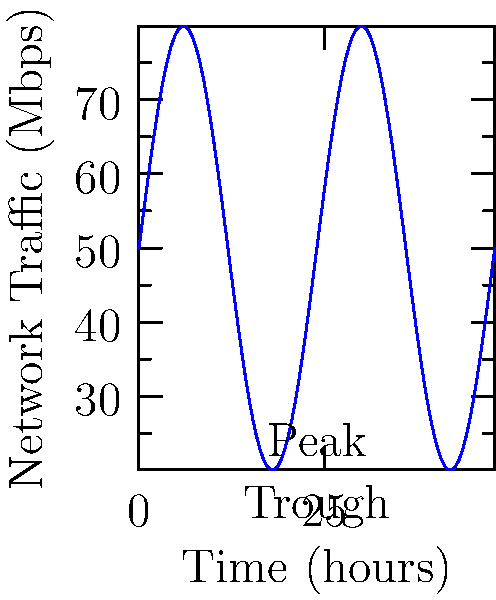As an ethical hacker analyzing network traffic patterns for a start-up, you observe that the traffic follows a sinusoidal pattern over a 24-hour period. The average traffic is 50 Mbps, with peaks reaching 80 Mbps and troughs at 20 Mbps. Using this information, construct a trigonometric function to model the network traffic $T(t)$ in Mbps as a function of time $t$ in hours. What is the period of this function? To construct the trigonometric function and find its period, we'll follow these steps:

1) The general form of a sinusoidal function is:
   $T(t) = A \sin(B(t-C)) + D$
   where $A$ is the amplitude, $B$ is related to the period, $C$ is the phase shift, and $D$ is the vertical shift.

2) From the given information:
   - The average traffic (vertical shift) $D = 50$ Mbps
   - The amplitude $A = (80 - 20)/2 = 30$ Mbps

3) The function oscillates between 20 and 80 Mbps:
   $T(t) = 30 \sin(B(t-C)) + 50$

4) The period of the function is 24 hours. For a sine function, the period is given by $\frac{2\pi}{B}$. So:
   $\frac{2\pi}{B} = 24$
   $B = \frac{2\pi}{24} = \frac{\pi}{12}$

5) The complete function is:
   $T(t) = 30 \sin(\frac{\pi}{12}(t-C)) + 50$

6) The phase shift $C$ is not necessary to determine for this question, as we're only asked about the period.

The period of the function is the time it takes for one complete cycle. In this case, it's given in the problem statement as 24 hours.
Answer: 24 hours 